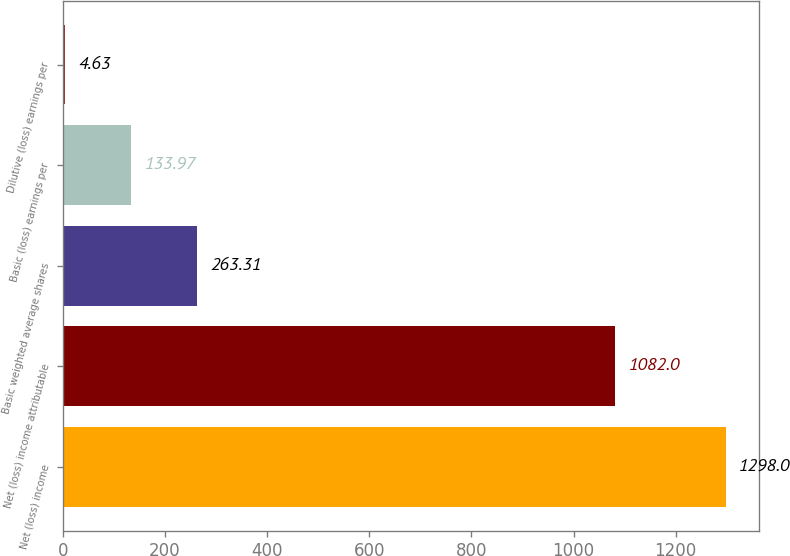<chart> <loc_0><loc_0><loc_500><loc_500><bar_chart><fcel>Net (loss) income<fcel>Net (loss) income attributable<fcel>Basic weighted average shares<fcel>Basic (loss) earnings per<fcel>Dilutive (loss) earnings per<nl><fcel>1298<fcel>1082<fcel>263.31<fcel>133.97<fcel>4.63<nl></chart> 